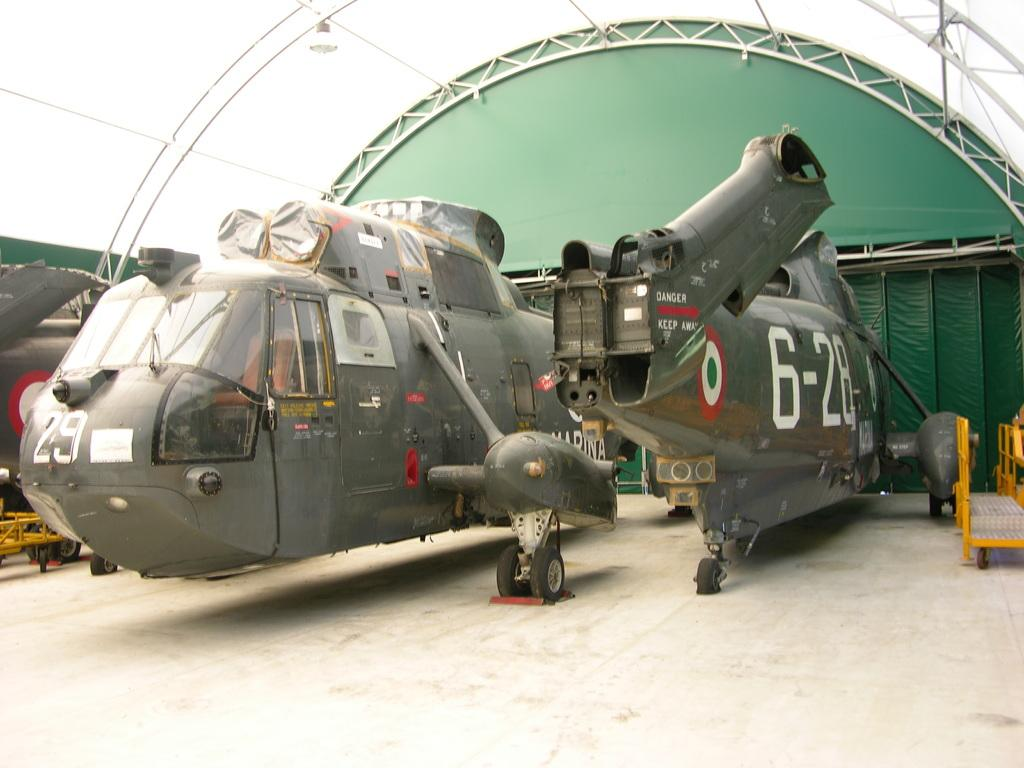<image>
Write a terse but informative summary of the picture. Two military helicopters, marked 29 and 6-28, sit partially disassembled. 